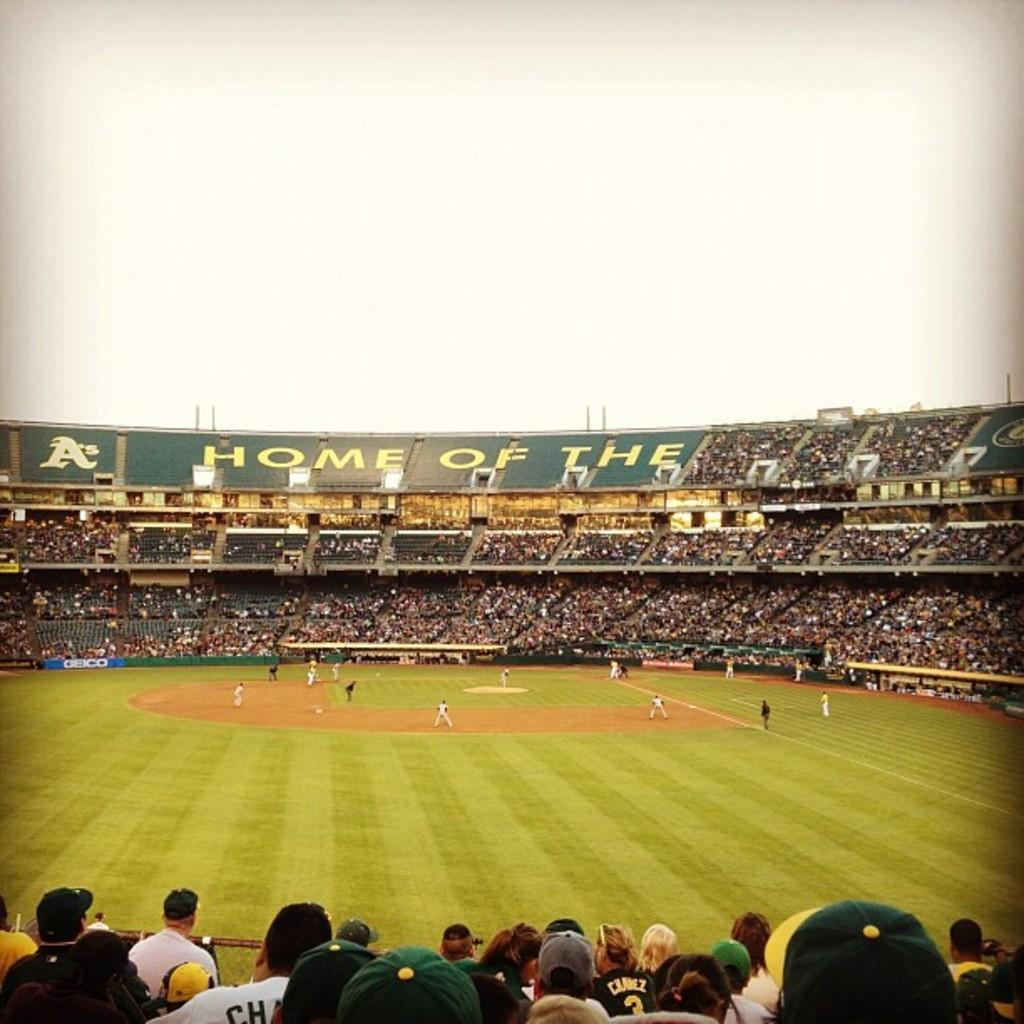<image>
Provide a brief description of the given image. The A's baseball field has strong attendence during a game. 